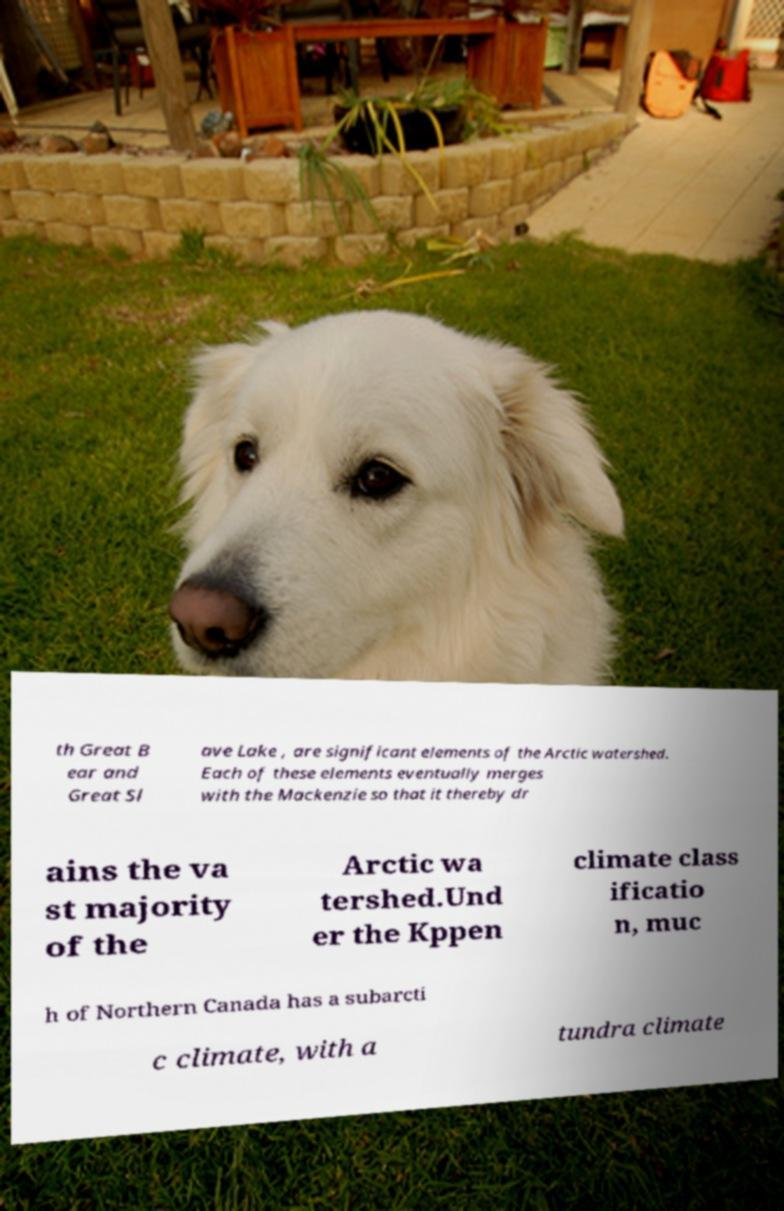I need the written content from this picture converted into text. Can you do that? th Great B ear and Great Sl ave Lake , are significant elements of the Arctic watershed. Each of these elements eventually merges with the Mackenzie so that it thereby dr ains the va st majority of the Arctic wa tershed.Und er the Kppen climate class ificatio n, muc h of Northern Canada has a subarcti c climate, with a tundra climate 